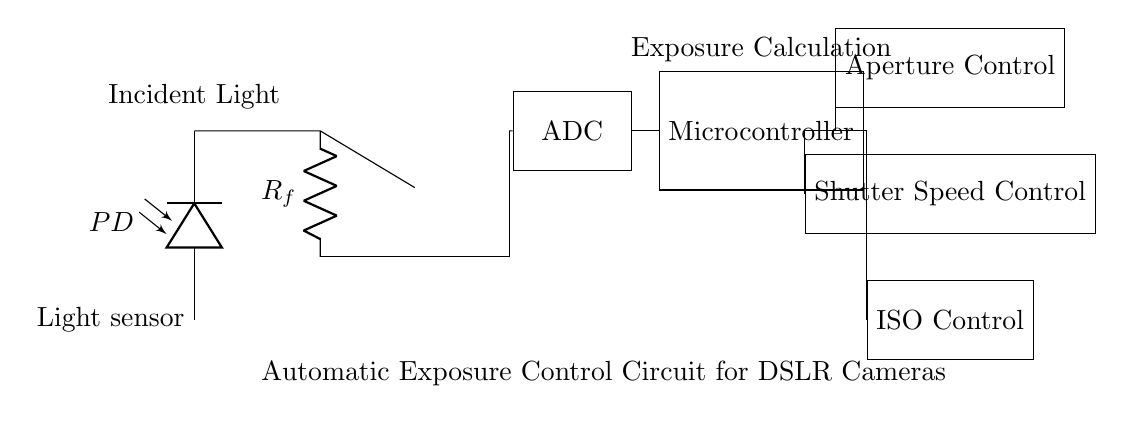What component is used as the light sensor? The light sensor in the circuit is represented by a photodiode labeled PD. This component is typically used to detect light intensity, which is necessary for the exposure control system.
Answer: Photodiode How is the output from the light sensor processed? The output from the light sensor, which is a voltage signal, is fed to an operational amplifier. The operational amplifier is configured to amplify the signal before it is sent to the next stage in the circuit, represented by the ADC.
Answer: Operational amplifier What does the ADC do in this circuit? The Analog-to-Digital Converter (ADC) takes the analog voltage signal from the operational amplifier and converts it into a digital signal that can be processed by the microcontroller for further calculations.
Answer: Converts analog to digital How many control functions are managed by the microcontroller? The microcontroller manages three control functions, which are aperture control, shutter speed control, and ISO control. Each function is designed to adjust different camera settings to achieve the desired exposure based on the calculated light levels.
Answer: Three What is the primary role of the microcontroller in this circuit? The microcontroller's primary role is to perform exposure calculations based on the digital signal it receives from the ADC. It uses this information to adjust aperture, shutter speed, and ISO settings automatically to achieve proper exposure.
Answer: Exposure calculation Which component adjusts the camera's aperture? The component responsible for adjusting the camera's aperture is labeled as "Aperture Control" in the circuit diagram. This component receives commands from the microcontroller based on light intensity measurements.
Answer: Aperture Control 